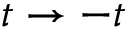<formula> <loc_0><loc_0><loc_500><loc_500>t \to - t</formula> 